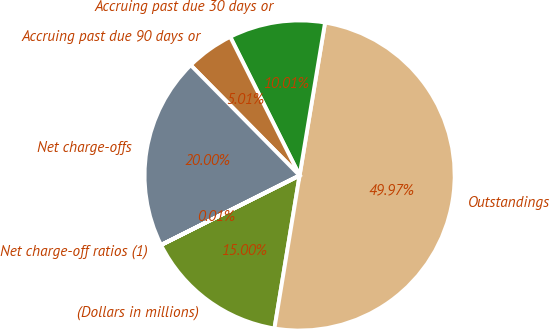Convert chart. <chart><loc_0><loc_0><loc_500><loc_500><pie_chart><fcel>(Dollars in millions)<fcel>Outstandings<fcel>Accruing past due 30 days or<fcel>Accruing past due 90 days or<fcel>Net charge-offs<fcel>Net charge-off ratios (1)<nl><fcel>15.0%<fcel>49.97%<fcel>10.01%<fcel>5.01%<fcel>20.0%<fcel>0.01%<nl></chart> 